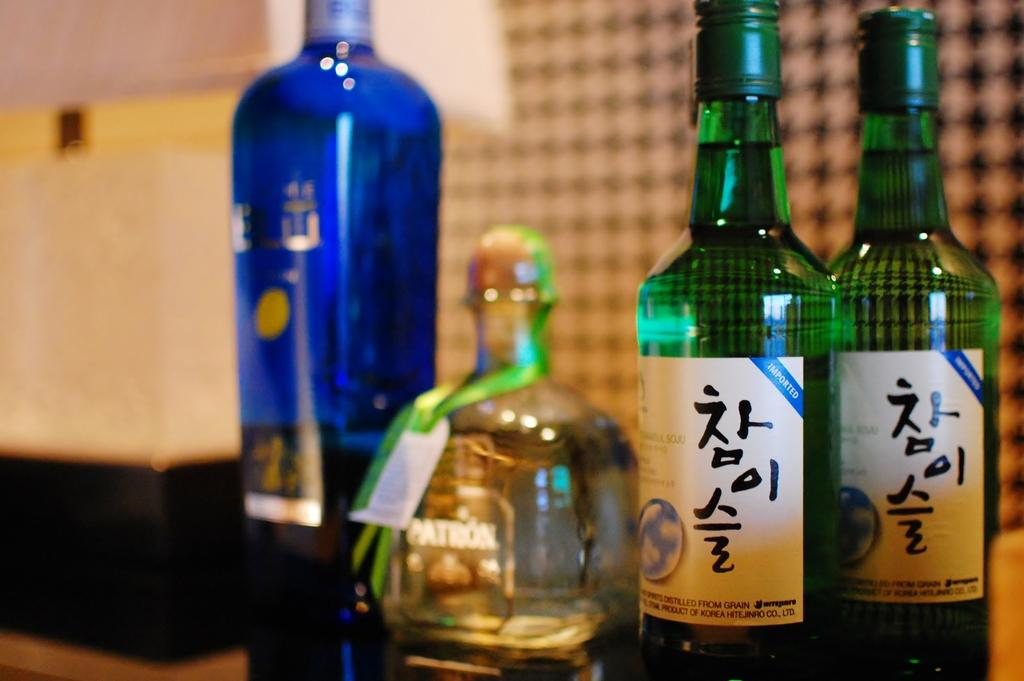<image>
Render a clear and concise summary of the photo. Several tall and short bottles that are labeled with Japanese characters. 